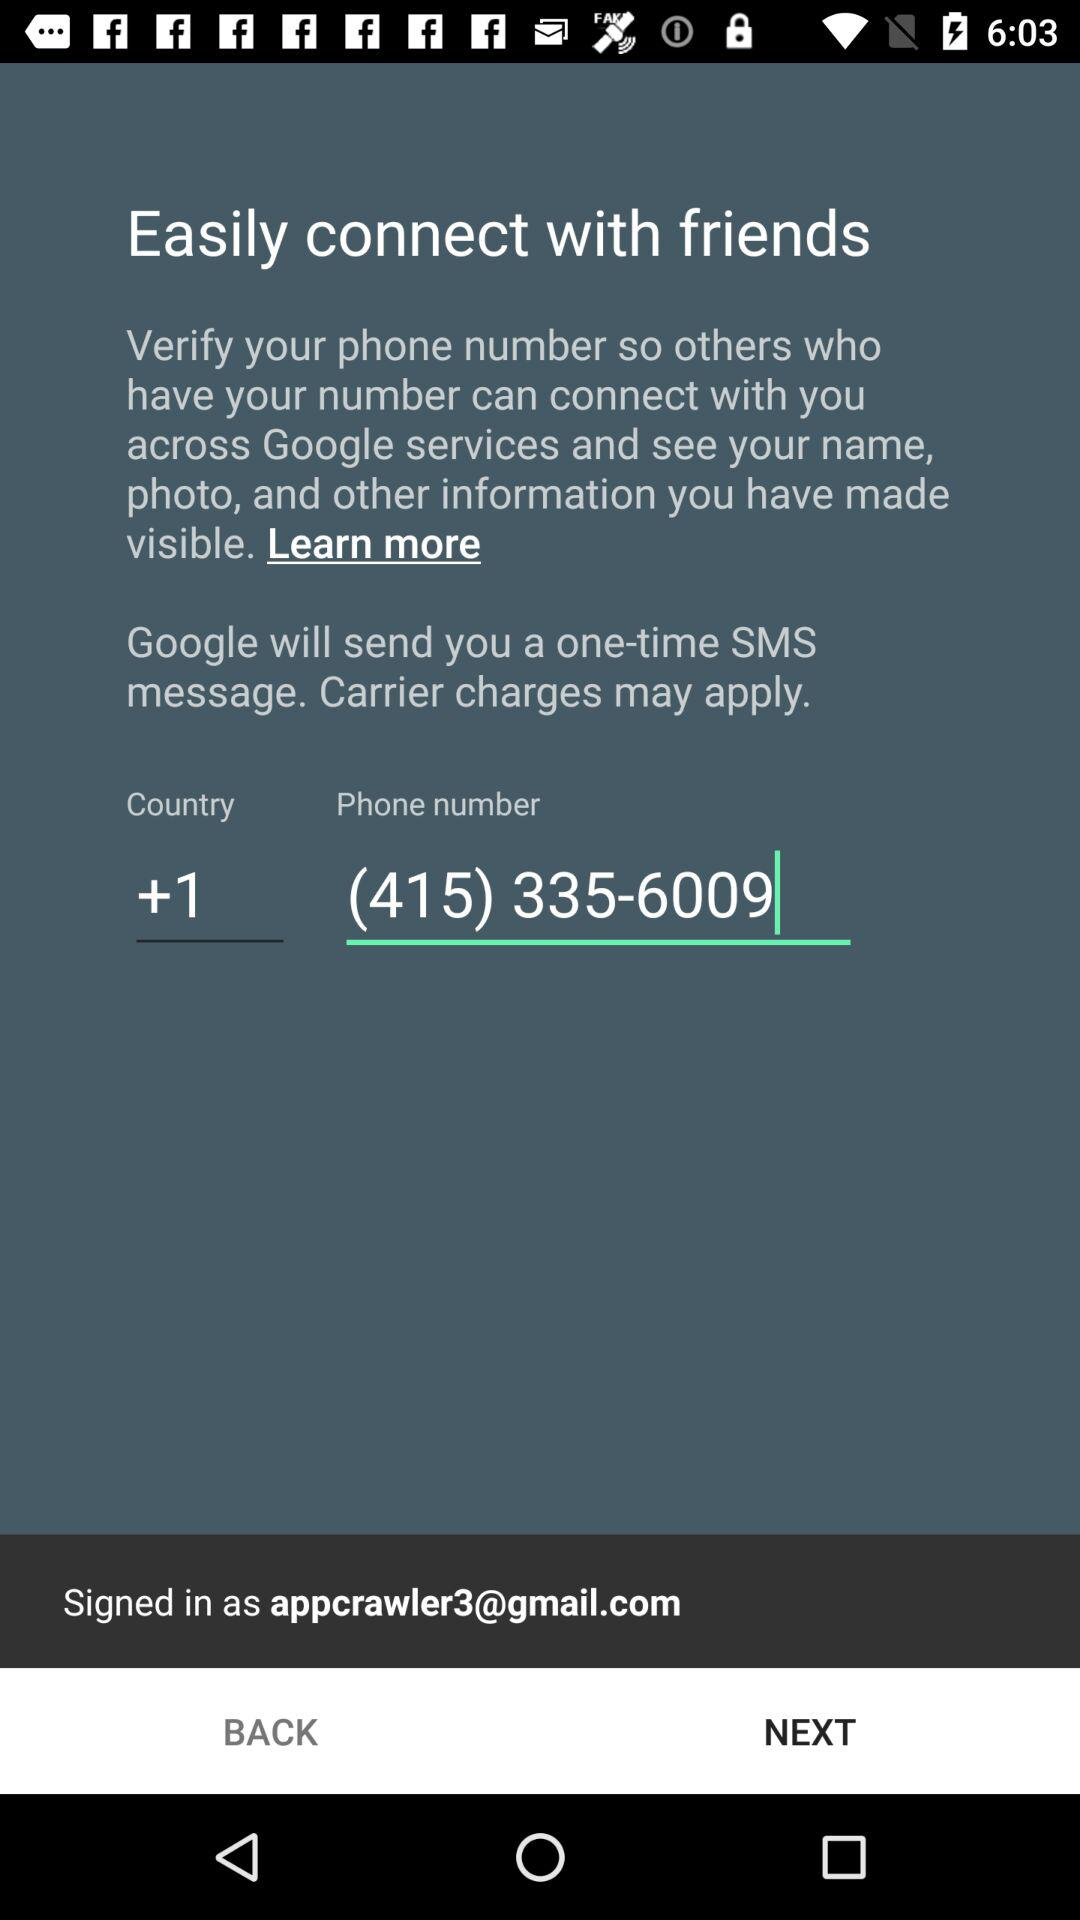What is the contact number? The contact number is (415) 335-6009. 